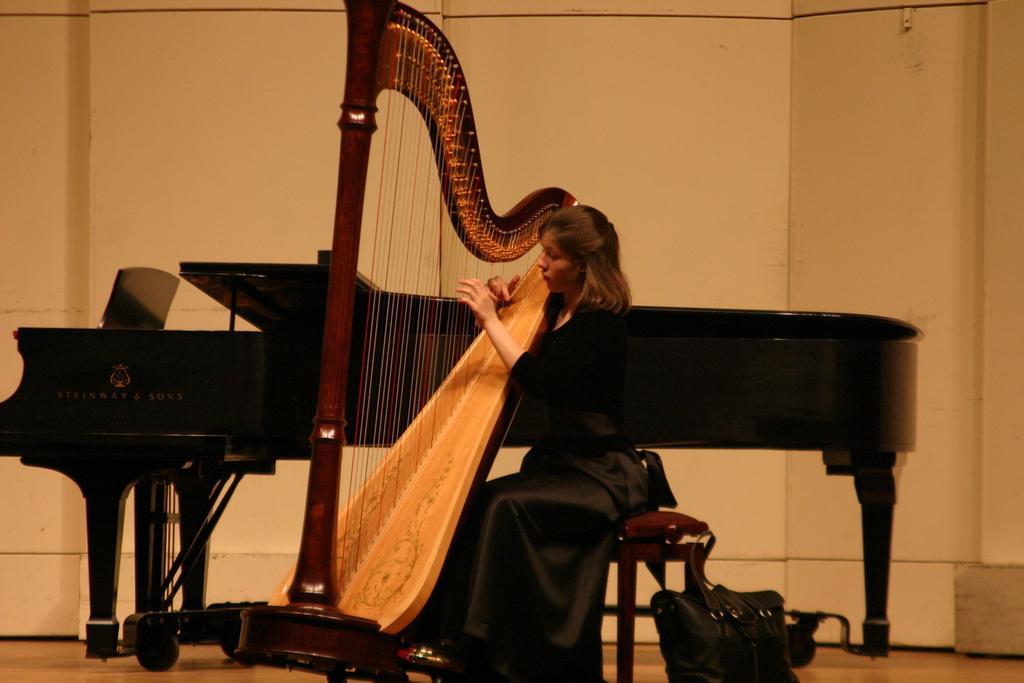Can you describe this image briefly? This image consists of a person who is sitting on a stool. There are some musical instruments. She is holding one of them and there is a bag in the bottom. She is wearing black color dress. 